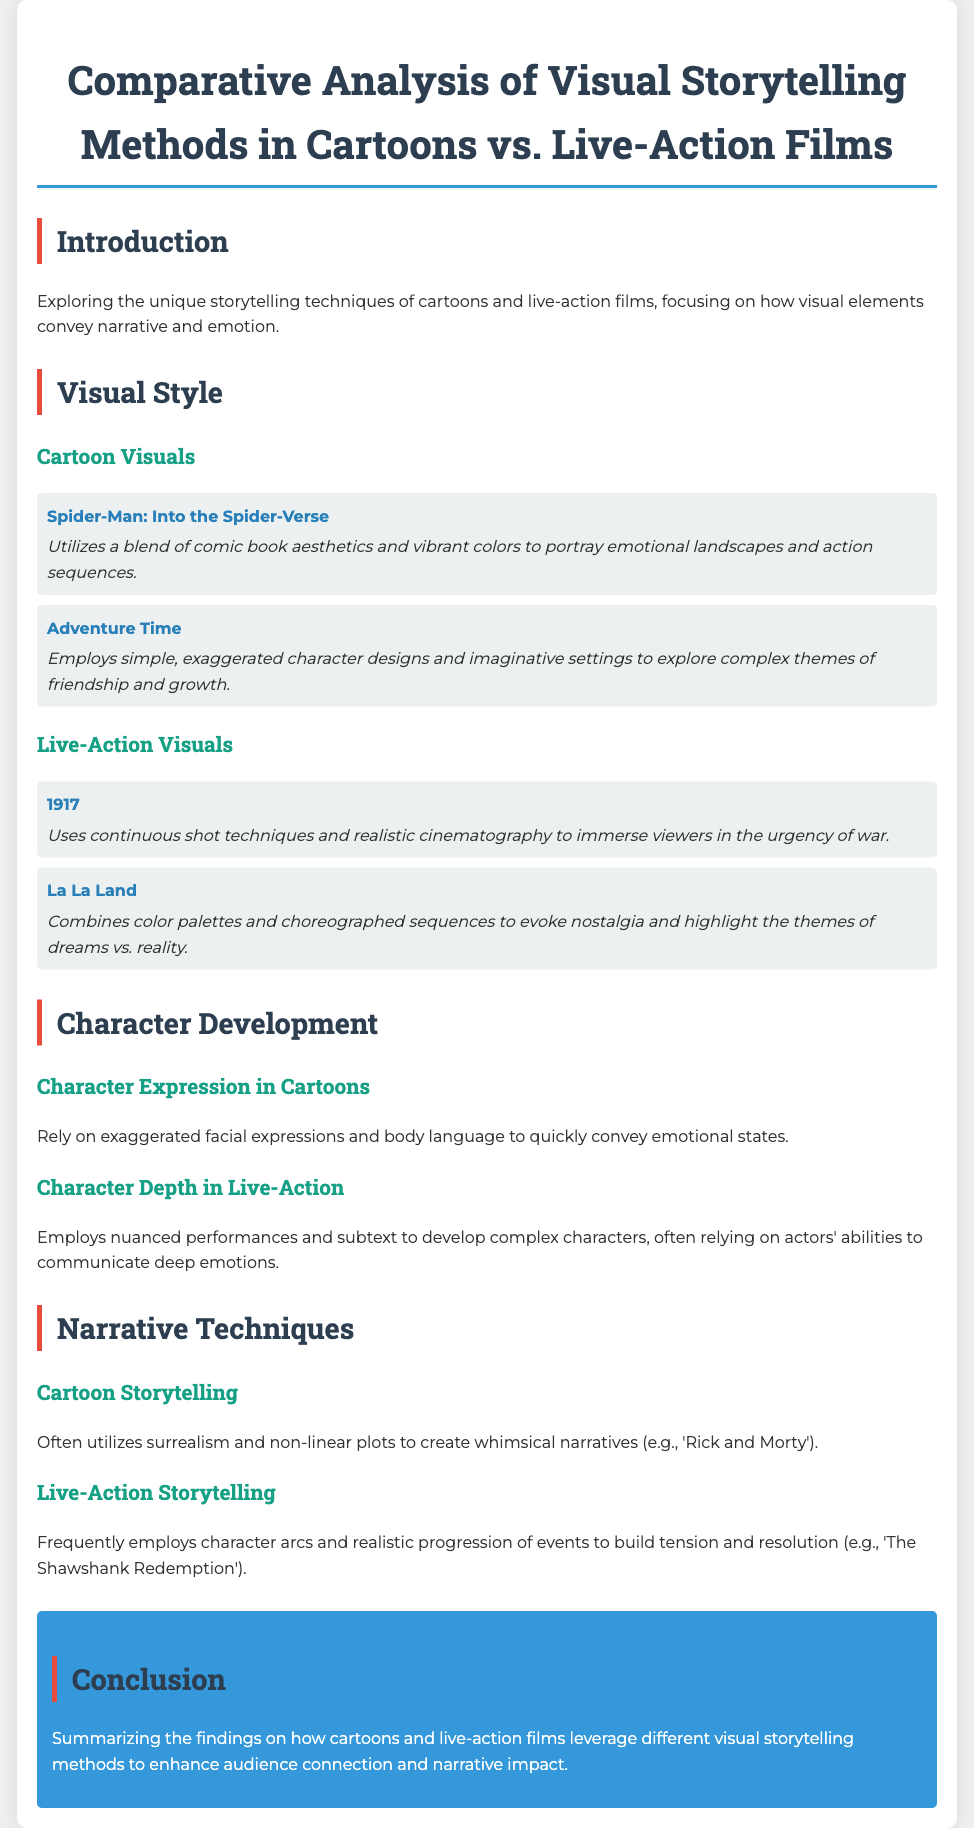What is the main focus of the document? The document explores the unique storytelling techniques of cartoons and live-action films, especially how visual elements convey narrative and emotion.
Answer: Storytelling techniques Which cartoon is mentioned as utilizing comic book aesthetics? "Spider-Man: Into the Spider-Verse" is noted for its blend of comic book aesthetics and vibrant colors.
Answer: Spider-Man: Into the Spider-Verse What element does "1917" use to create immersion? "1917" employs continuous shot techniques to immerse viewers in the urgency of war.
Answer: Continuous shot techniques How do cartoons convey emotional states? Cartoons rely on exaggerated facial expressions and body language to convey emotional states quickly.
Answer: Exaggerated facial expressions What technique does live-action storytelling often employ? Live-action storytelling frequently employs character arcs to build tension and resolution.
Answer: Character arcs 